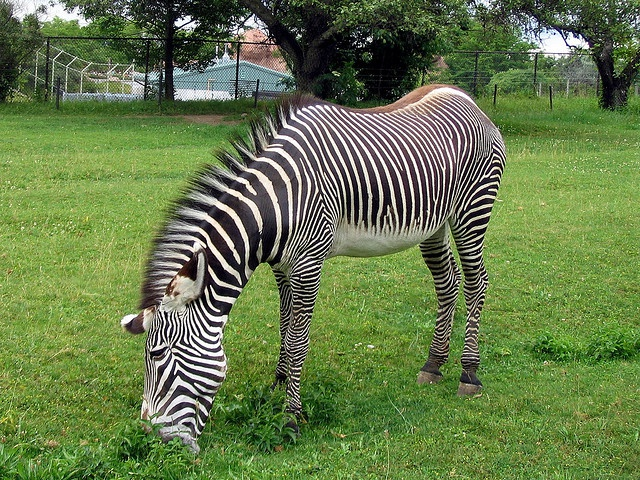Describe the objects in this image and their specific colors. I can see a zebra in gray, black, white, and darkgray tones in this image. 